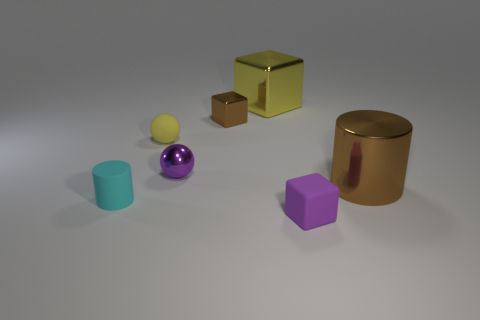Add 3 small purple balls. How many objects exist? 10 Subtract all balls. How many objects are left? 5 Add 4 purple objects. How many purple objects are left? 6 Add 2 big yellow things. How many big yellow things exist? 3 Subtract 0 purple cylinders. How many objects are left? 7 Subtract all large brown cylinders. Subtract all tiny things. How many objects are left? 1 